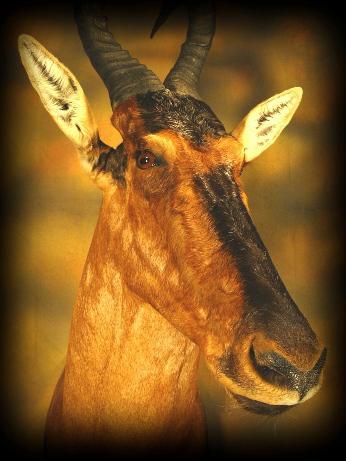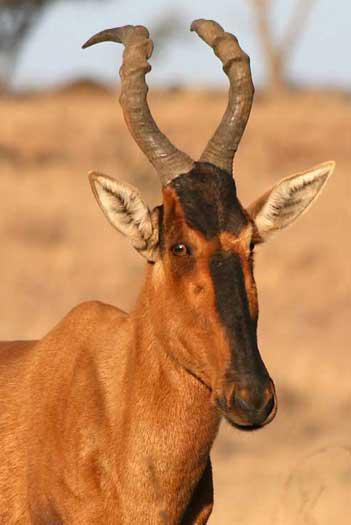The first image is the image on the left, the second image is the image on the right. For the images shown, is this caption "There are more than two horned animals in the grassy field." true? Answer yes or no. No. 